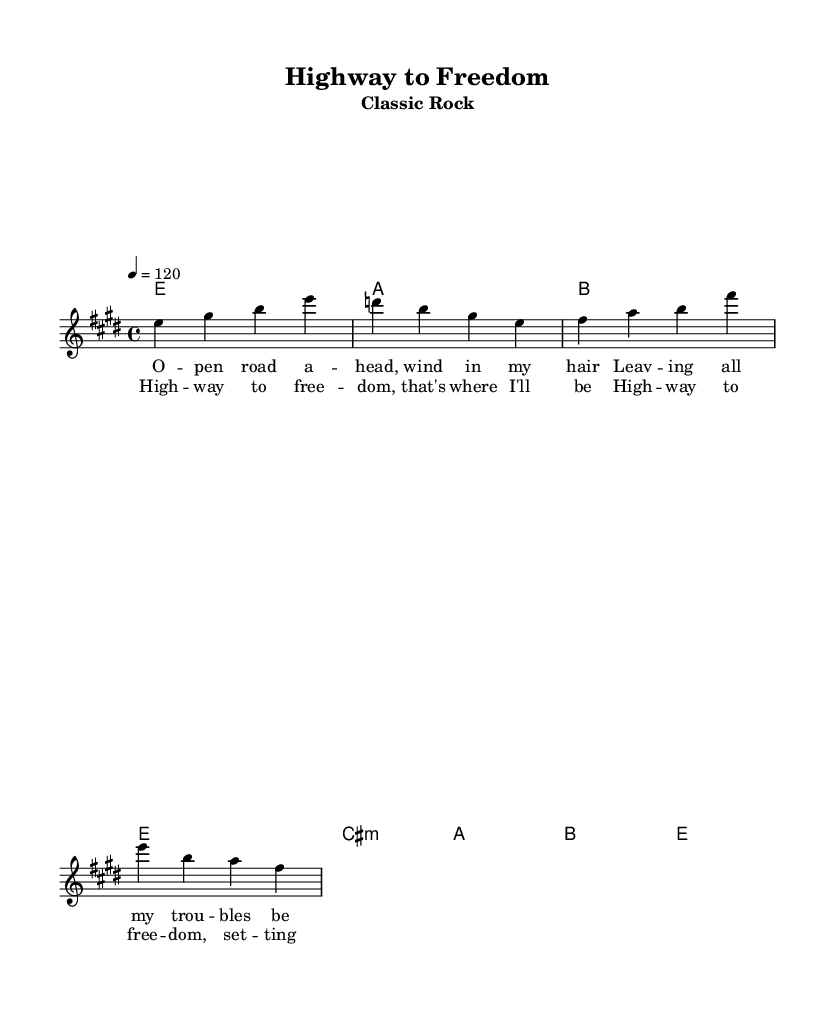What is the key signature of this music? The key signature is E major, which contains four sharps: F#, C#, G#, and D#. The presence of these sharps indicates that the piece is in E major, as E is the tonic of this key.
Answer: E major What is the time signature of the piece? The time signature is 4/4, indicating that there are four beats in each measure and a quarter note receives one beat. This is a common time signature used in many popular songs, giving it a steady and predictable rhythm.
Answer: 4/4 What is the tempo marking for this composition? The tempo marking indicates a speed of 120 beats per minute, represented in the sheet music by "4 = 120". This means that there are 120 quarter notes in one minute, suggesting a moderately fast pace for the music.
Answer: 120 How many measures are there in the melody section? The melody section displayed has a total of two measures, which can be determined by the presence of the bar lines in the notation. Each measure is separated by a vertical line, and the end of the melody shows the conclusion of these two measures.
Answer: 2 What is the main theme of the chorus lyrics? The main theme of the chorus lyrics expresses the idea of freedom and liberation, with lines like "Highway to freedom, that's where I'll be". This theme resonates with the open road and a sense of adventure, common in classic rock anthems.
Answer: Freedom What chords accompany the melody in the verse section? The chords that accompany the melody in the verse section are E major, A major, and B major, which are indicated above the melody as harmonic support. These chords provide a foundation for the melody and create a pleasing harmonic structure.
Answer: E, A, B How does the melody resolve at the end of the chorus? The melody resolves on the E note at the end of the chorus, which is the tonic note of the key signature. This resolution gives a sense of completion and satisfaction, typical for the concluding section of a song.
Answer: E 